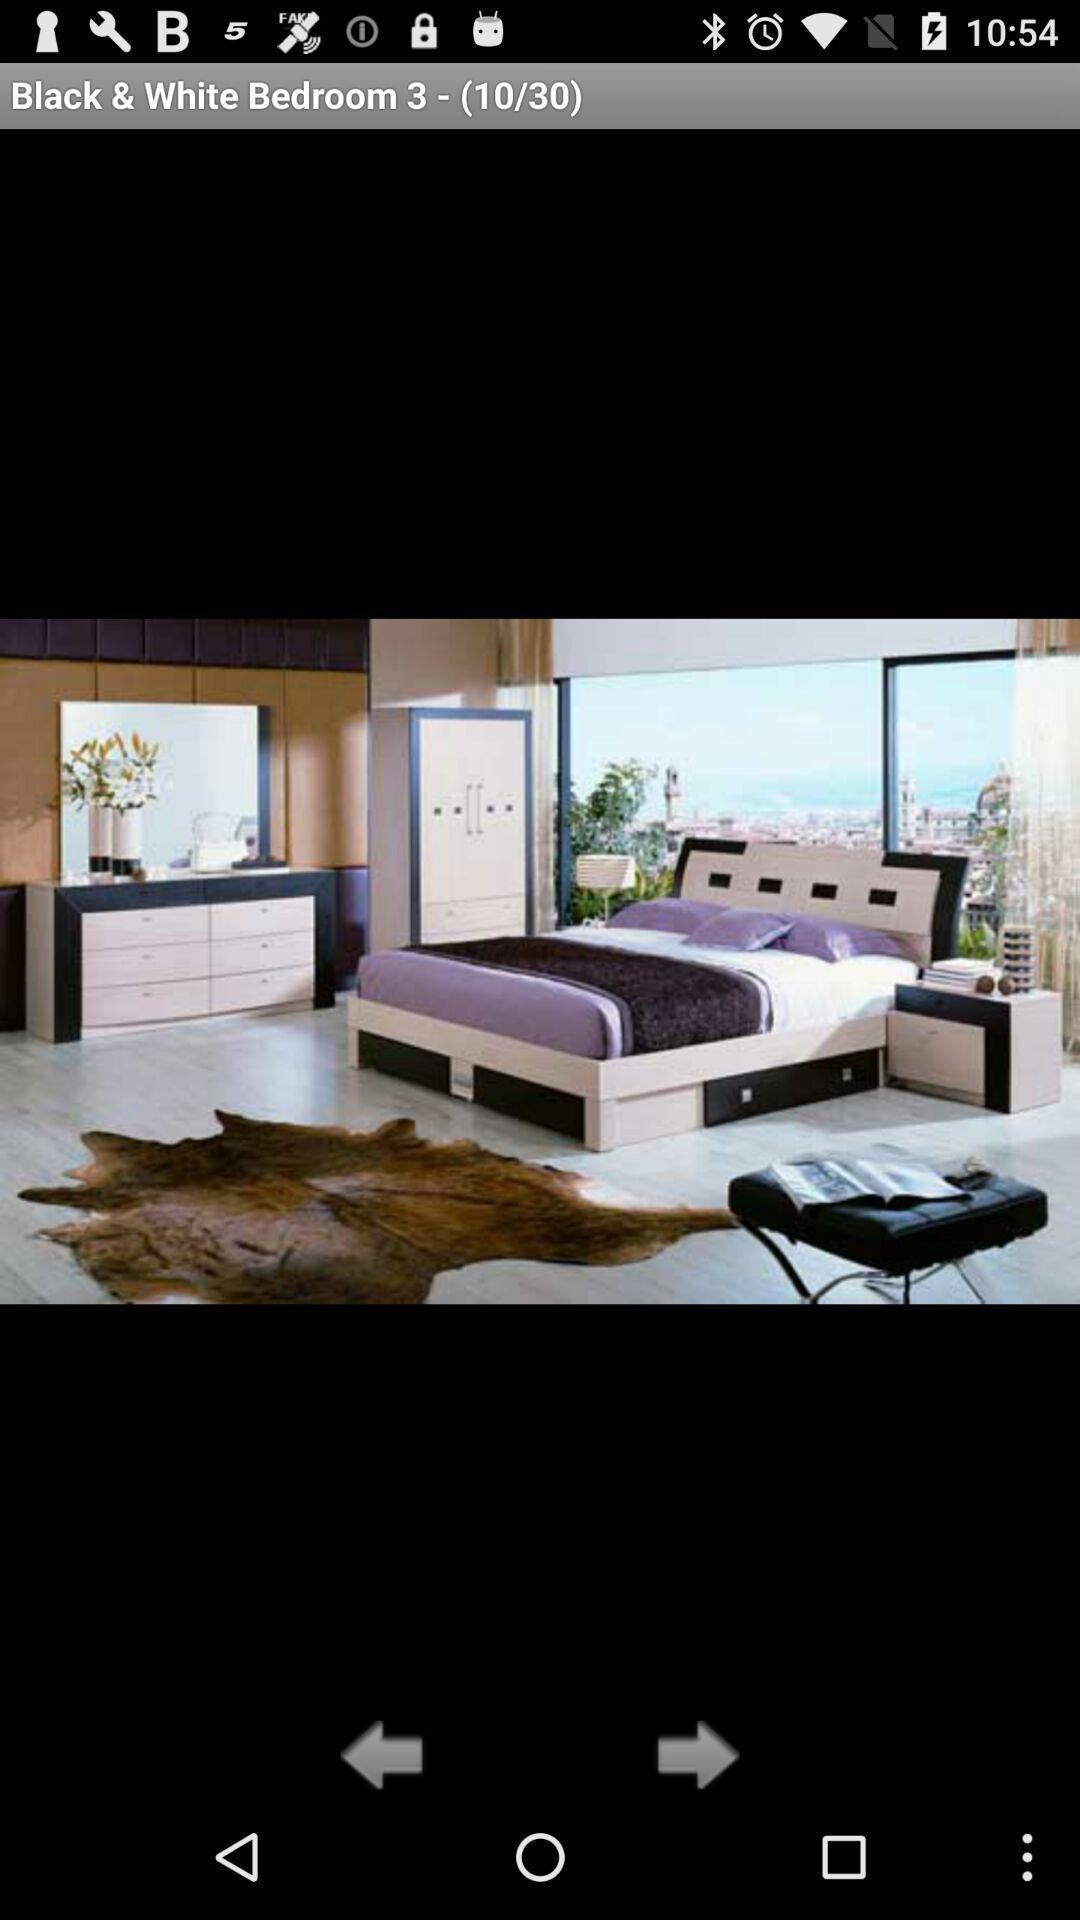Currently, we are on what image number? You are on page number 10. 